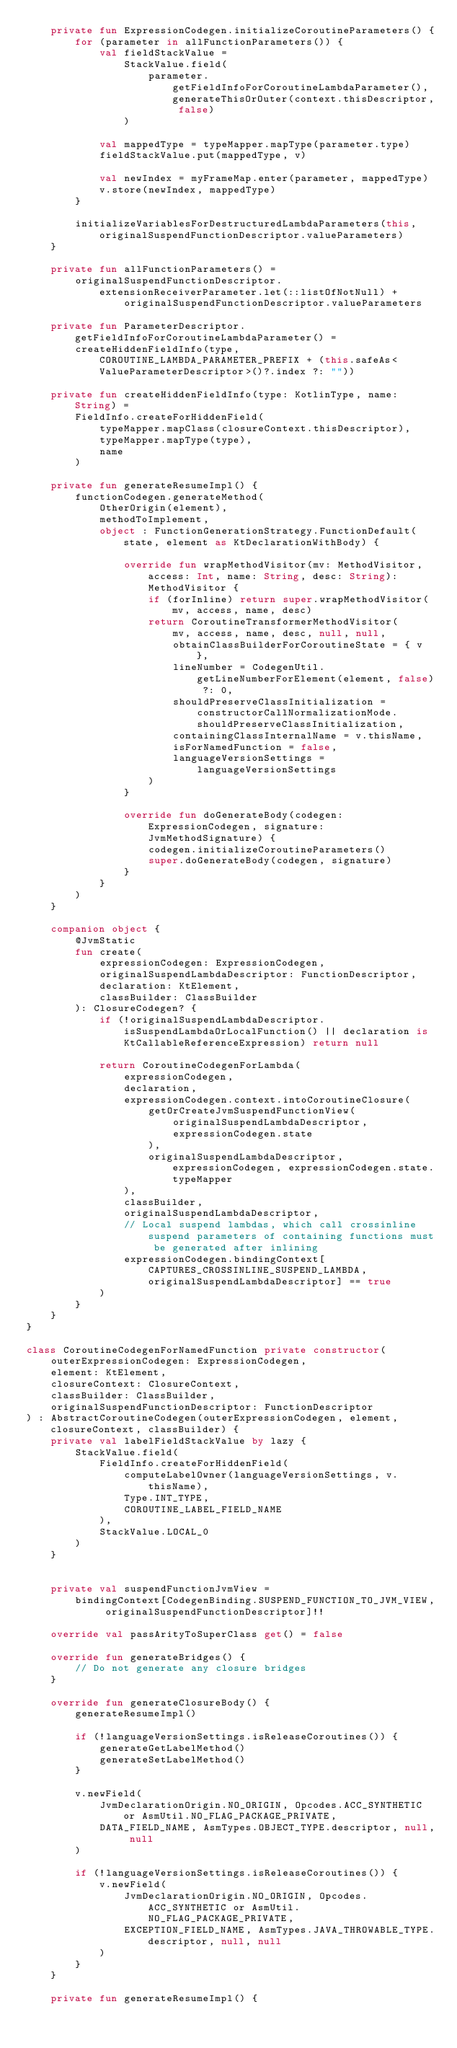Convert code to text. <code><loc_0><loc_0><loc_500><loc_500><_Kotlin_>    private fun ExpressionCodegen.initializeCoroutineParameters() {
        for (parameter in allFunctionParameters()) {
            val fieldStackValue =
                StackValue.field(
                    parameter.getFieldInfoForCoroutineLambdaParameter(), generateThisOrOuter(context.thisDescriptor, false)
                )

            val mappedType = typeMapper.mapType(parameter.type)
            fieldStackValue.put(mappedType, v)

            val newIndex = myFrameMap.enter(parameter, mappedType)
            v.store(newIndex, mappedType)
        }

        initializeVariablesForDestructuredLambdaParameters(this, originalSuspendFunctionDescriptor.valueParameters)
    }

    private fun allFunctionParameters() =
        originalSuspendFunctionDescriptor.extensionReceiverParameter.let(::listOfNotNull) +
                originalSuspendFunctionDescriptor.valueParameters

    private fun ParameterDescriptor.getFieldInfoForCoroutineLambdaParameter() =
        createHiddenFieldInfo(type, COROUTINE_LAMBDA_PARAMETER_PREFIX + (this.safeAs<ValueParameterDescriptor>()?.index ?: ""))

    private fun createHiddenFieldInfo(type: KotlinType, name: String) =
        FieldInfo.createForHiddenField(
            typeMapper.mapClass(closureContext.thisDescriptor),
            typeMapper.mapType(type),
            name
        )

    private fun generateResumeImpl() {
        functionCodegen.generateMethod(
            OtherOrigin(element),
            methodToImplement,
            object : FunctionGenerationStrategy.FunctionDefault(state, element as KtDeclarationWithBody) {

                override fun wrapMethodVisitor(mv: MethodVisitor, access: Int, name: String, desc: String): MethodVisitor {
                    if (forInline) return super.wrapMethodVisitor(mv, access, name, desc)
                    return CoroutineTransformerMethodVisitor(
                        mv, access, name, desc, null, null,
                        obtainClassBuilderForCoroutineState = { v },
                        lineNumber = CodegenUtil.getLineNumberForElement(element, false) ?: 0,
                        shouldPreserveClassInitialization = constructorCallNormalizationMode.shouldPreserveClassInitialization,
                        containingClassInternalName = v.thisName,
                        isForNamedFunction = false,
                        languageVersionSettings = languageVersionSettings
                    )
                }

                override fun doGenerateBody(codegen: ExpressionCodegen, signature: JvmMethodSignature) {
                    codegen.initializeCoroutineParameters()
                    super.doGenerateBody(codegen, signature)
                }
            }
        )
    }

    companion object {
        @JvmStatic
        fun create(
            expressionCodegen: ExpressionCodegen,
            originalSuspendLambdaDescriptor: FunctionDescriptor,
            declaration: KtElement,
            classBuilder: ClassBuilder
        ): ClosureCodegen? {
            if (!originalSuspendLambdaDescriptor.isSuspendLambdaOrLocalFunction() || declaration is KtCallableReferenceExpression) return null

            return CoroutineCodegenForLambda(
                expressionCodegen,
                declaration,
                expressionCodegen.context.intoCoroutineClosure(
                    getOrCreateJvmSuspendFunctionView(
                        originalSuspendLambdaDescriptor,
                        expressionCodegen.state
                    ),
                    originalSuspendLambdaDescriptor, expressionCodegen, expressionCodegen.state.typeMapper
                ),
                classBuilder,
                originalSuspendLambdaDescriptor,
                // Local suspend lambdas, which call crossinline suspend parameters of containing functions must be generated after inlining
                expressionCodegen.bindingContext[CAPTURES_CROSSINLINE_SUSPEND_LAMBDA, originalSuspendLambdaDescriptor] == true
            )
        }
    }
}

class CoroutineCodegenForNamedFunction private constructor(
    outerExpressionCodegen: ExpressionCodegen,
    element: KtElement,
    closureContext: ClosureContext,
    classBuilder: ClassBuilder,
    originalSuspendFunctionDescriptor: FunctionDescriptor
) : AbstractCoroutineCodegen(outerExpressionCodegen, element, closureContext, classBuilder) {
    private val labelFieldStackValue by lazy {
        StackValue.field(
            FieldInfo.createForHiddenField(
                computeLabelOwner(languageVersionSettings, v.thisName),
                Type.INT_TYPE,
                COROUTINE_LABEL_FIELD_NAME
            ),
            StackValue.LOCAL_0
        )
    }


    private val suspendFunctionJvmView =
        bindingContext[CodegenBinding.SUSPEND_FUNCTION_TO_JVM_VIEW, originalSuspendFunctionDescriptor]!!

    override val passArityToSuperClass get() = false

    override fun generateBridges() {
        // Do not generate any closure bridges
    }

    override fun generateClosureBody() {
        generateResumeImpl()

        if (!languageVersionSettings.isReleaseCoroutines()) {
            generateGetLabelMethod()
            generateSetLabelMethod()
        }

        v.newField(
            JvmDeclarationOrigin.NO_ORIGIN, Opcodes.ACC_SYNTHETIC or AsmUtil.NO_FLAG_PACKAGE_PRIVATE,
            DATA_FIELD_NAME, AsmTypes.OBJECT_TYPE.descriptor, null, null
        )

        if (!languageVersionSettings.isReleaseCoroutines()) {
            v.newField(
                JvmDeclarationOrigin.NO_ORIGIN, Opcodes.ACC_SYNTHETIC or AsmUtil.NO_FLAG_PACKAGE_PRIVATE,
                EXCEPTION_FIELD_NAME, AsmTypes.JAVA_THROWABLE_TYPE.descriptor, null, null
            )
        }
    }

    private fun generateResumeImpl() {</code> 